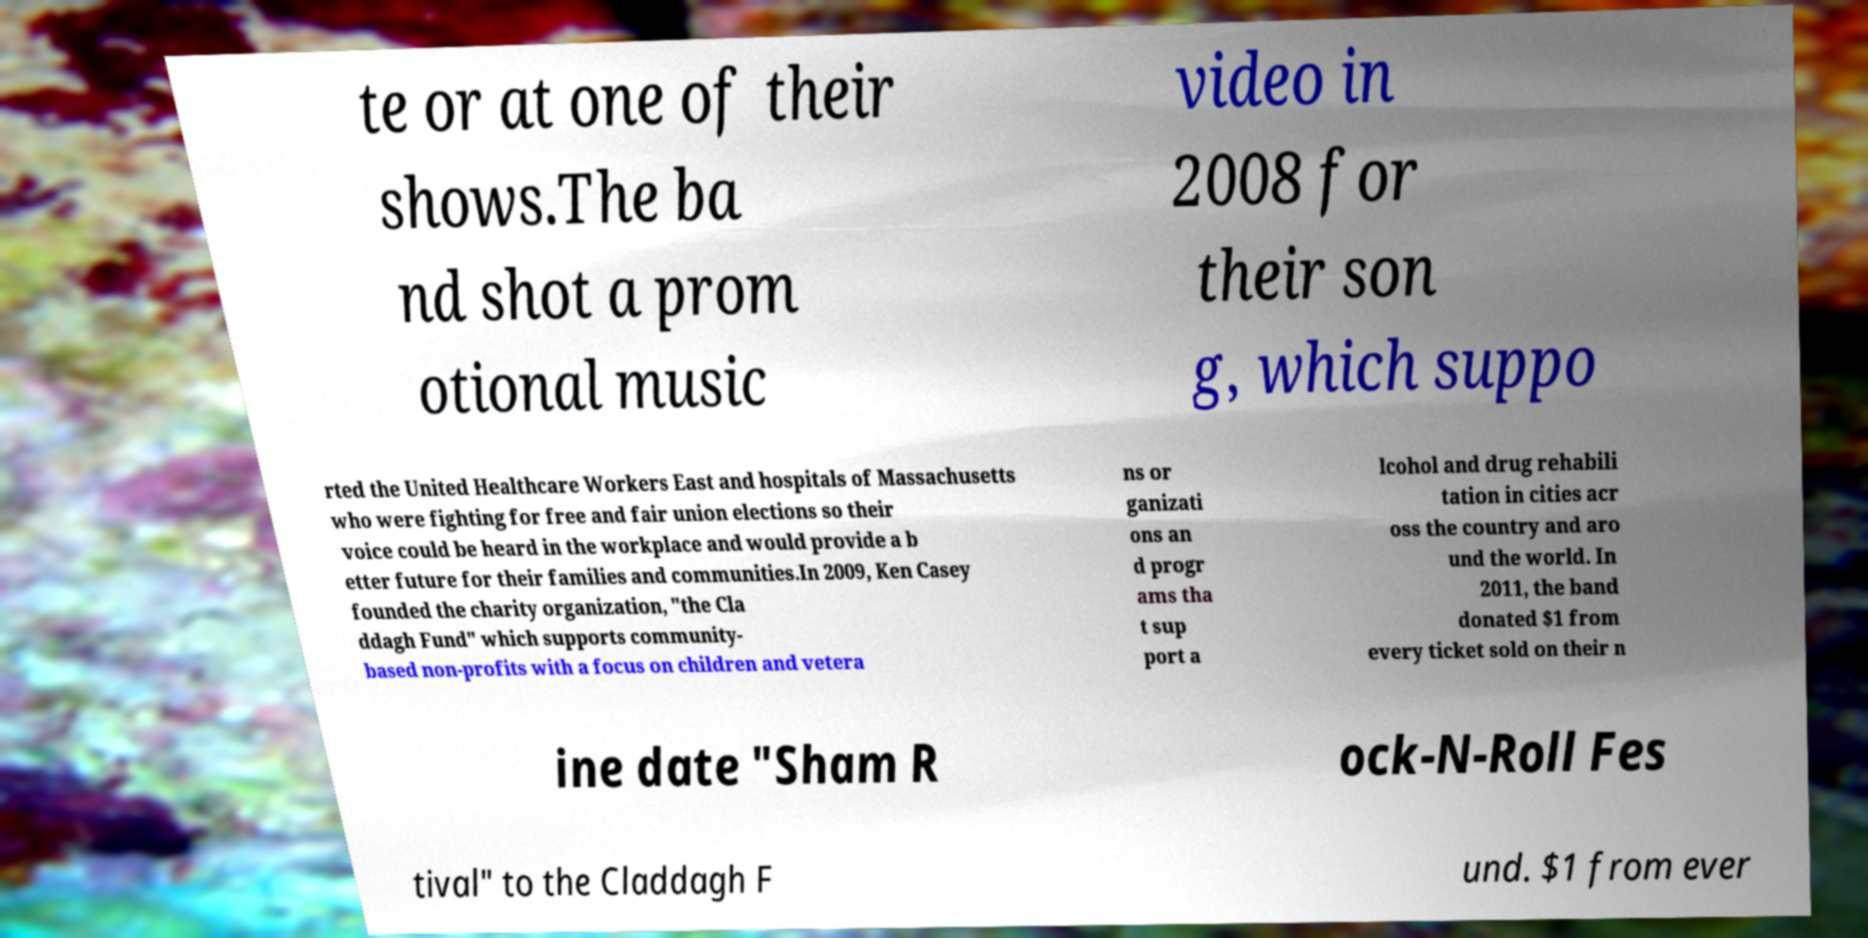Please read and relay the text visible in this image. What does it say? te or at one of their shows.The ba nd shot a prom otional music video in 2008 for their son g, which suppo rted the United Healthcare Workers East and hospitals of Massachusetts who were fighting for free and fair union elections so their voice could be heard in the workplace and would provide a b etter future for their families and communities.In 2009, Ken Casey founded the charity organization, "the Cla ddagh Fund" which supports community- based non-profits with a focus on children and vetera ns or ganizati ons an d progr ams tha t sup port a lcohol and drug rehabili tation in cities acr oss the country and aro und the world. In 2011, the band donated $1 from every ticket sold on their n ine date "Sham R ock-N-Roll Fes tival" to the Claddagh F und. $1 from ever 